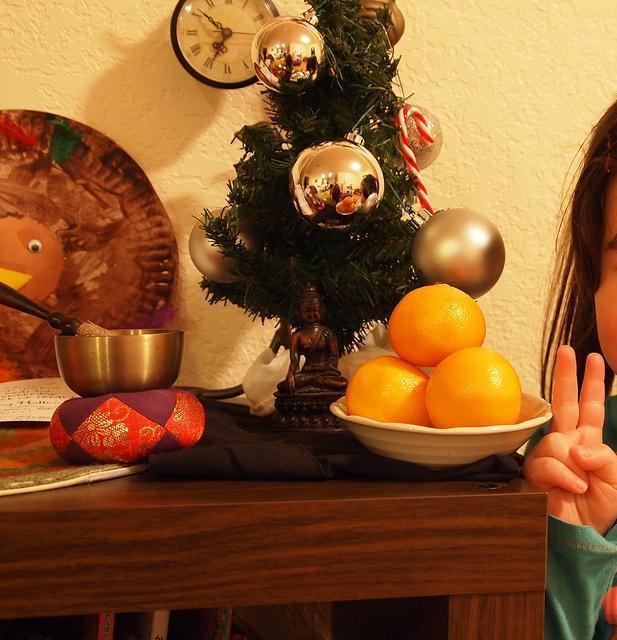How many bowls are there?
Give a very brief answer. 2. How many oranges can be seen?
Give a very brief answer. 3. 